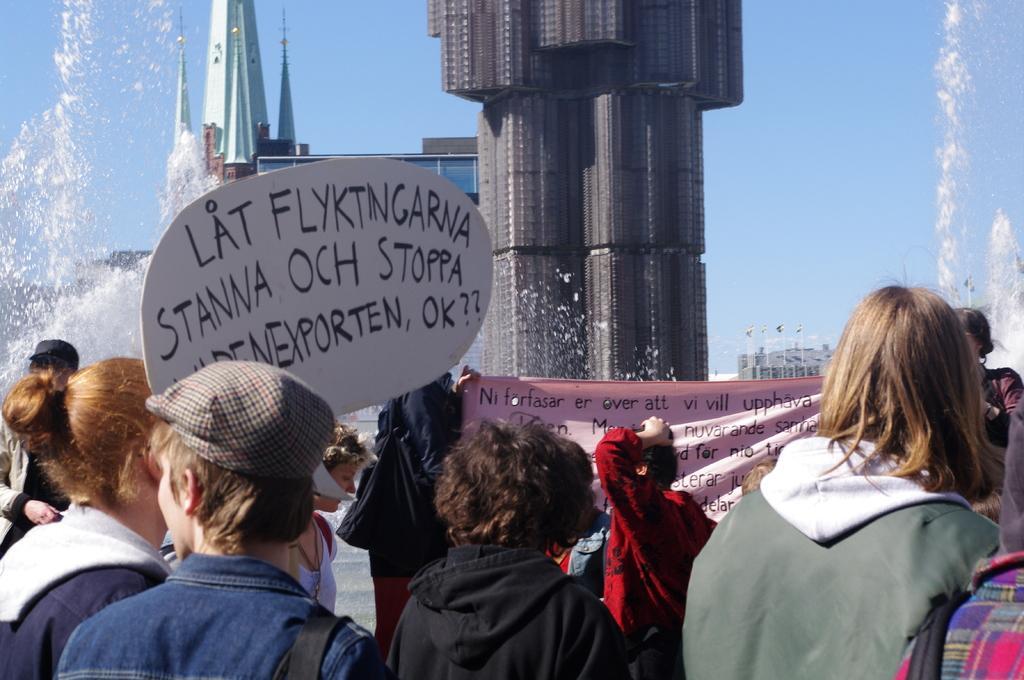Please provide a concise description of this image. In this picture, there are people at the bottom. In the center, there is a woman wearing a black jacket. Towards the right, there is another woman wearing green jacket. Towards the left, there is a person wearing blue shirt. Before him, there is a placard with some text. On the top, there are buildings. Towards the left and right, there is water. 